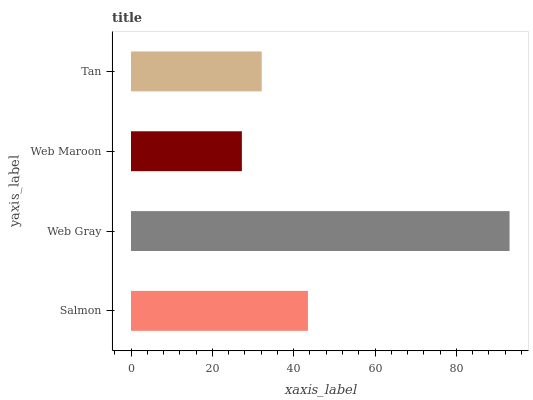Is Web Maroon the minimum?
Answer yes or no. Yes. Is Web Gray the maximum?
Answer yes or no. Yes. Is Web Gray the minimum?
Answer yes or no. No. Is Web Maroon the maximum?
Answer yes or no. No. Is Web Gray greater than Web Maroon?
Answer yes or no. Yes. Is Web Maroon less than Web Gray?
Answer yes or no. Yes. Is Web Maroon greater than Web Gray?
Answer yes or no. No. Is Web Gray less than Web Maroon?
Answer yes or no. No. Is Salmon the high median?
Answer yes or no. Yes. Is Tan the low median?
Answer yes or no. Yes. Is Tan the high median?
Answer yes or no. No. Is Web Gray the low median?
Answer yes or no. No. 